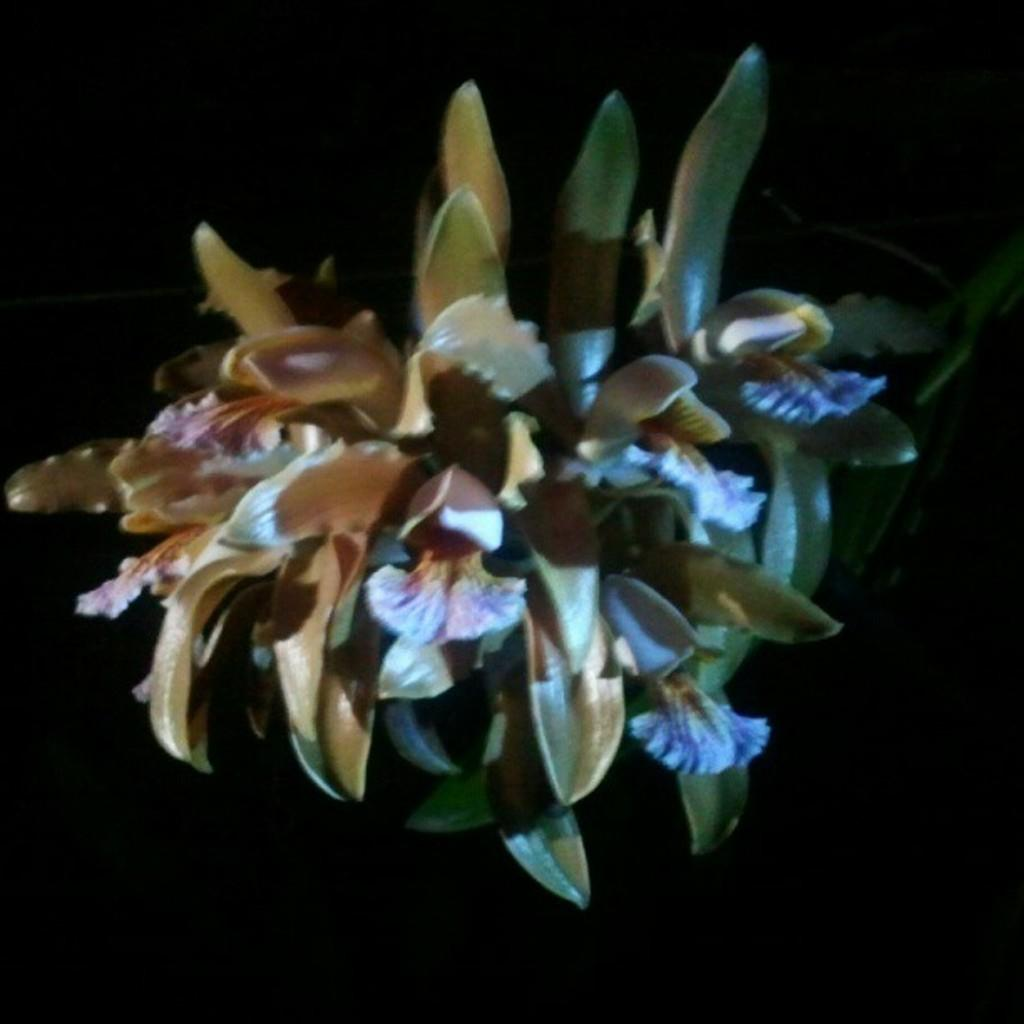What is the main subject of the image? The main subject of the image is a flower plant. Can you describe the background of the image? The background of the plant is blurred. What type of liquid is being poured on the flower plant in the image? There is no liquid being poured on the flower plant in the image; it features a flower plant with a blurred background. 